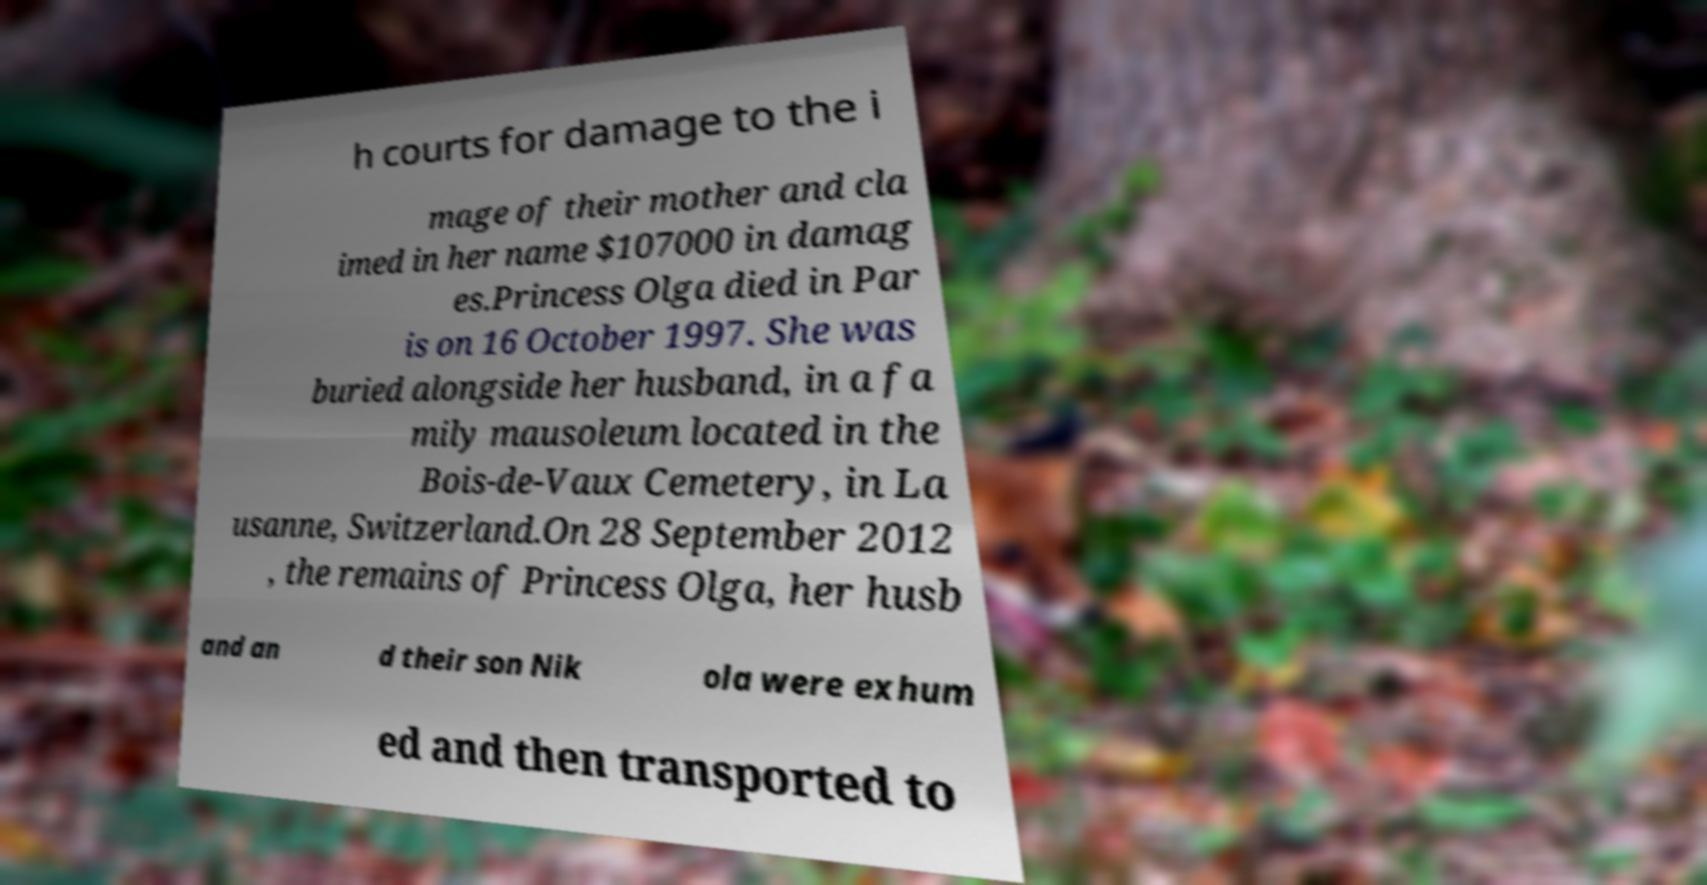Can you accurately transcribe the text from the provided image for me? h courts for damage to the i mage of their mother and cla imed in her name $107000 in damag es.Princess Olga died in Par is on 16 October 1997. She was buried alongside her husband, in a fa mily mausoleum located in the Bois-de-Vaux Cemetery, in La usanne, Switzerland.On 28 September 2012 , the remains of Princess Olga, her husb and an d their son Nik ola were exhum ed and then transported to 